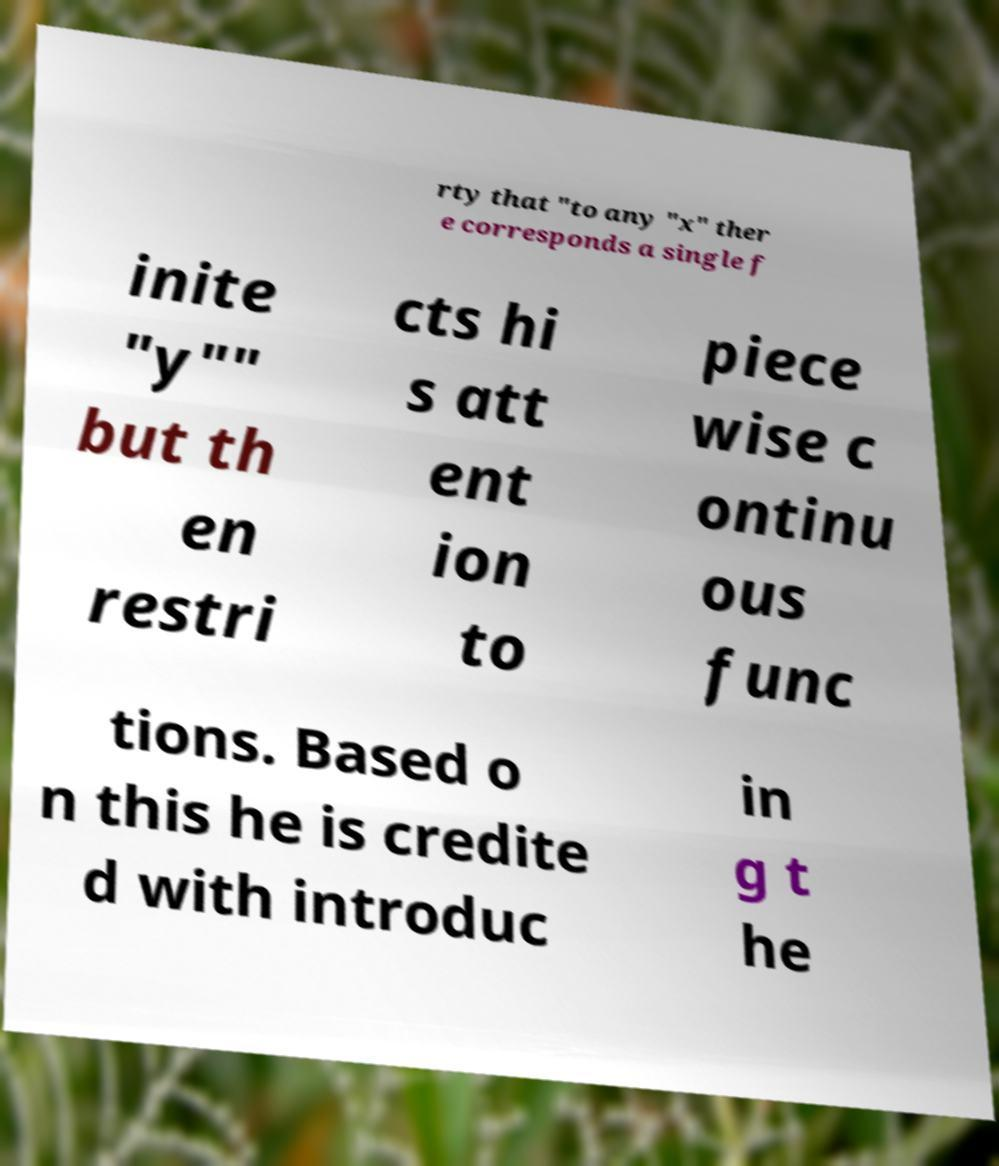Could you extract and type out the text from this image? rty that "to any "x" ther e corresponds a single f inite "y"" but th en restri cts hi s att ent ion to piece wise c ontinu ous func tions. Based o n this he is credite d with introduc in g t he 